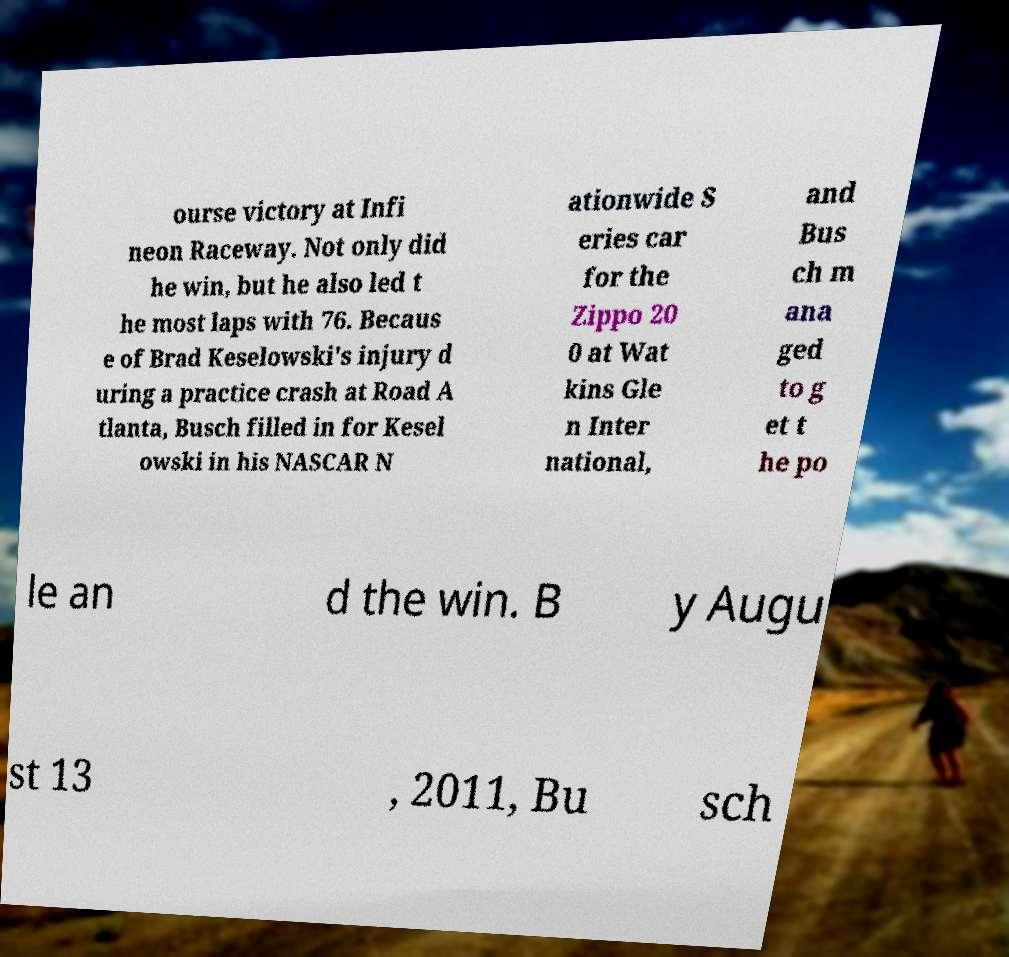Can you accurately transcribe the text from the provided image for me? ourse victory at Infi neon Raceway. Not only did he win, but he also led t he most laps with 76. Becaus e of Brad Keselowski's injury d uring a practice crash at Road A tlanta, Busch filled in for Kesel owski in his NASCAR N ationwide S eries car for the Zippo 20 0 at Wat kins Gle n Inter national, and Bus ch m ana ged to g et t he po le an d the win. B y Augu st 13 , 2011, Bu sch 